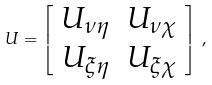Convert formula to latex. <formula><loc_0><loc_0><loc_500><loc_500>U = \left [ \begin{array} { c c } U _ { \nu \eta } & U _ { \nu \chi } \\ U _ { \xi \eta } & U _ { \xi \chi } \end{array} \right ] \, ,</formula> 